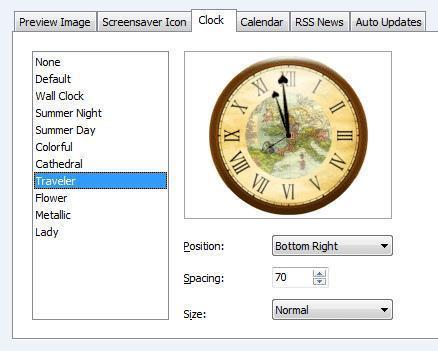How many people are wearing a green shirt?
Give a very brief answer. 0. 